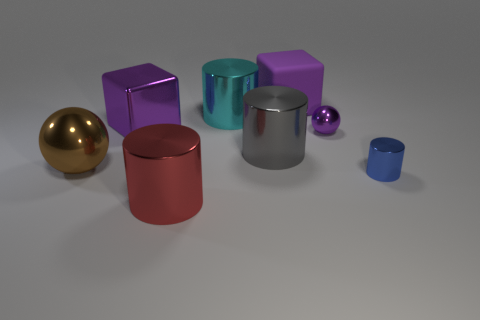Subtract 1 cylinders. How many cylinders are left? 3 Add 1 cyan shiny cylinders. How many objects exist? 9 Subtract all balls. How many objects are left? 6 Subtract all big shiny balls. Subtract all purple rubber blocks. How many objects are left? 6 Add 6 purple metallic things. How many purple metallic things are left? 8 Add 3 large purple matte cubes. How many large purple matte cubes exist? 4 Subtract 0 green cylinders. How many objects are left? 8 